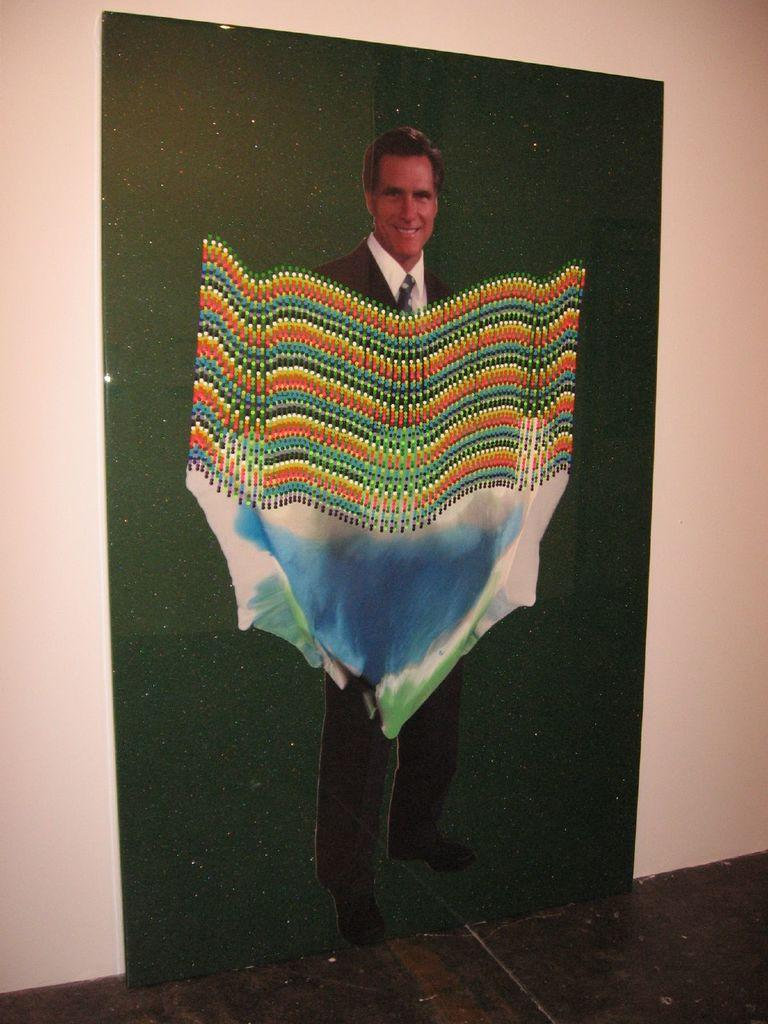What is on the wall in the image? There is a painting on the wall. What does the painting depict? The painting depicts a man. How has the image of the man been altered? The man's image has been edited. What type of clothing is the man in the painting wearing? The man in the painting is wearing a coat, a tie, and a shirt. What type of coast can be seen in the painting? There is no coast visible in the painting; it depicts a man wearing a coat, a tie, and a shirt. What type of competition is the scarecrow participating in within the painting? There is no scarecrow present in the painting; it depicts a man wearing a coat, a tie, and a shirt. 